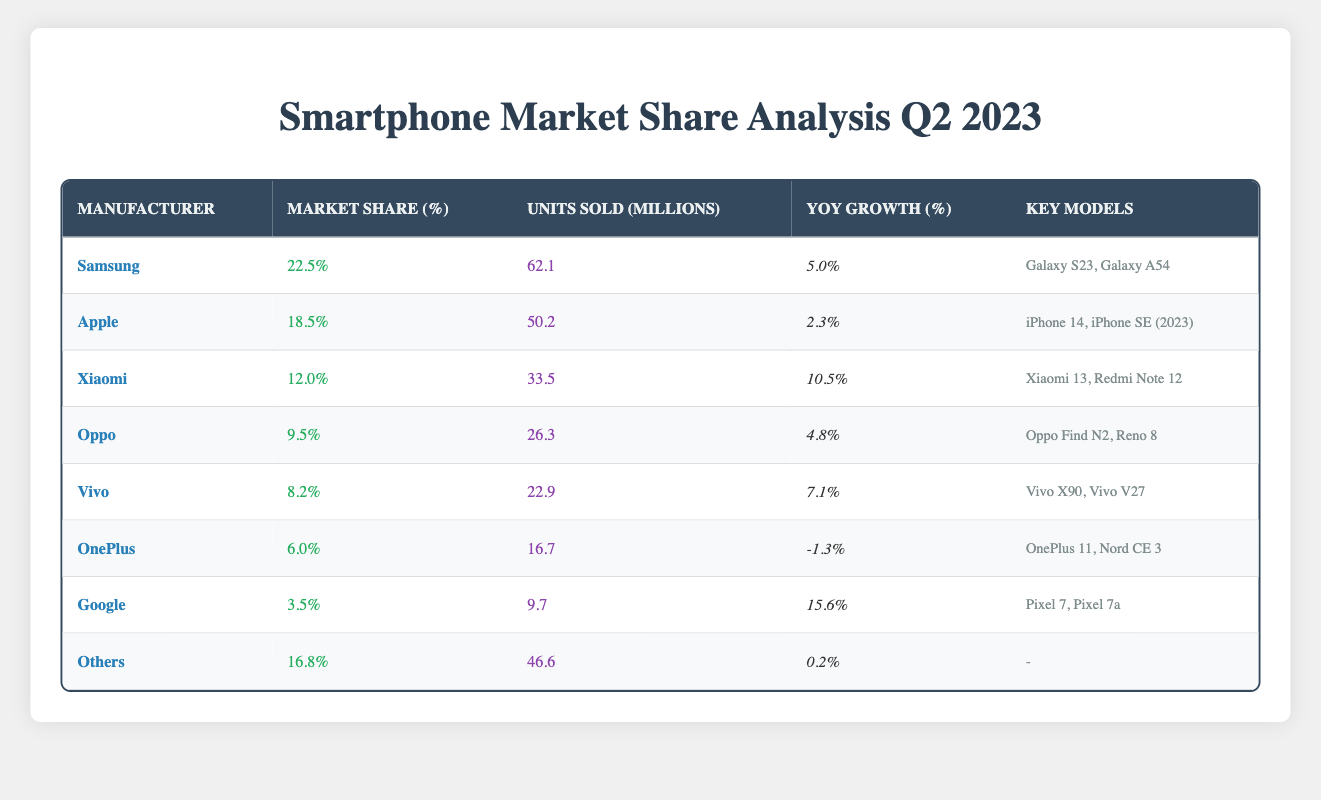What is the market share percentage for Samsung? According to the table, Samsung has a market share percentage of 22.5%.
Answer: 22.5% Which manufacturer has the highest year-on-year growth? By examining the "YoY Growth (%)" column, Xiaomi has the highest growth at 10.5%.
Answer: Xiaomi How many units did Apple sell in millions? The table states that Apple sold 50.2 million units in Q2 2023.
Answer: 50.2 million What is the combined market share of the top three manufacturers? The top three manufacturers are Samsung (22.5%), Apple (18.5%), and Xiaomi (12.0%). Adding them together: 22.5 + 18.5 + 12.0 = 53.0%.
Answer: 53.0% Did OnePlus experience a year-on-year growth in Q2 2023? Looking at OnePlus's YoY Growth, which is -1.3%, it indicates that they did not experience growth.
Answer: No Which manufacturer sold the least number of units? When reviewing the "Units Sold (Millions)" column, Google sold the least with 9.7 million units.
Answer: Google What is the average market share percentage of all manufacturers listed? The total market share percentage can be calculated as: 22.5 + 18.5 + 12.0 + 9.5 + 8.2 + 6.0 + 3.5 + 16.8 = 96.0%. There are 8 manufacturers, so the average is 96.0 / 8 = 12.0%.
Answer: 12.0% How many more units did Samsung sell compared to Vivo? Samsung sold 62.1 million units and Vivo sold 22.9 million units. The difference is 62.1 - 22.9 = 39.2 million units.
Answer: 39.2 million Is the percentage growth for Google higher than that of Oppo? Google has a growth of 15.6% and Oppo has 4.8%; since 15.6% > 4.8%, it confirms that Google’s growth is indeed higher.
Answer: Yes What percentage of total units sold is accounted for by Others category? The total units sold by Others is 46.6 million. Adding all the units sold gives (62.1 + 50.2 + 33.5 + 26.3 + 22.9 + 16.7 + 9.7 + 46.6) = 267.0 million total units. The percentage for Others is (46.6 / 267.0) * 100 = 17.4%.
Answer: 17.4% 